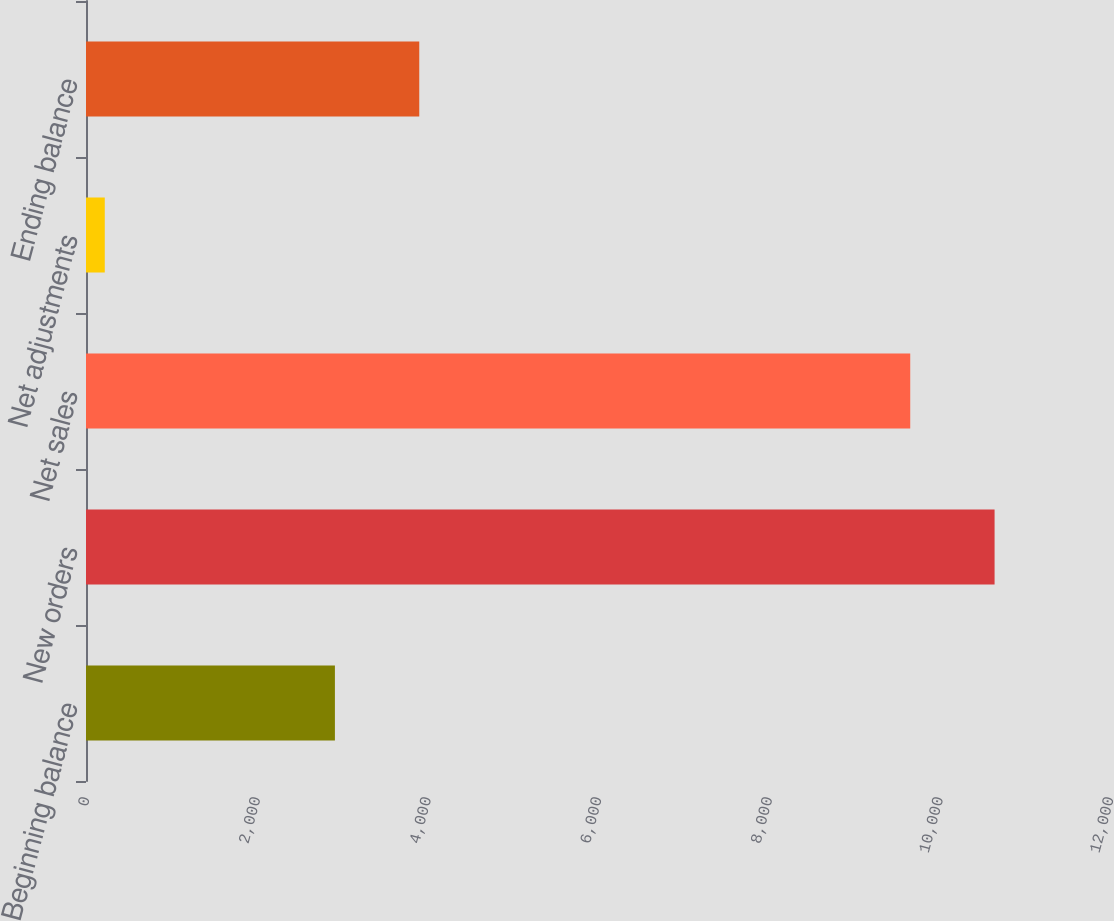<chart> <loc_0><loc_0><loc_500><loc_500><bar_chart><fcel>Beginning balance<fcel>New orders<fcel>Net sales<fcel>Net adjustments<fcel>Ending balance<nl><fcel>2917<fcel>10647.4<fcel>9659<fcel>220<fcel>3905.4<nl></chart> 